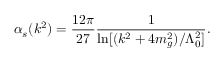<formula> <loc_0><loc_0><loc_500><loc_500>\alpha _ { s } ( k ^ { 2 } ) = \frac { 1 2 \pi } { 2 7 } \frac { 1 } { \ln [ ( k ^ { 2 } + 4 m _ { g } ^ { 2 } ) / \Lambda _ { 0 } ^ { 2 } ] } .</formula> 